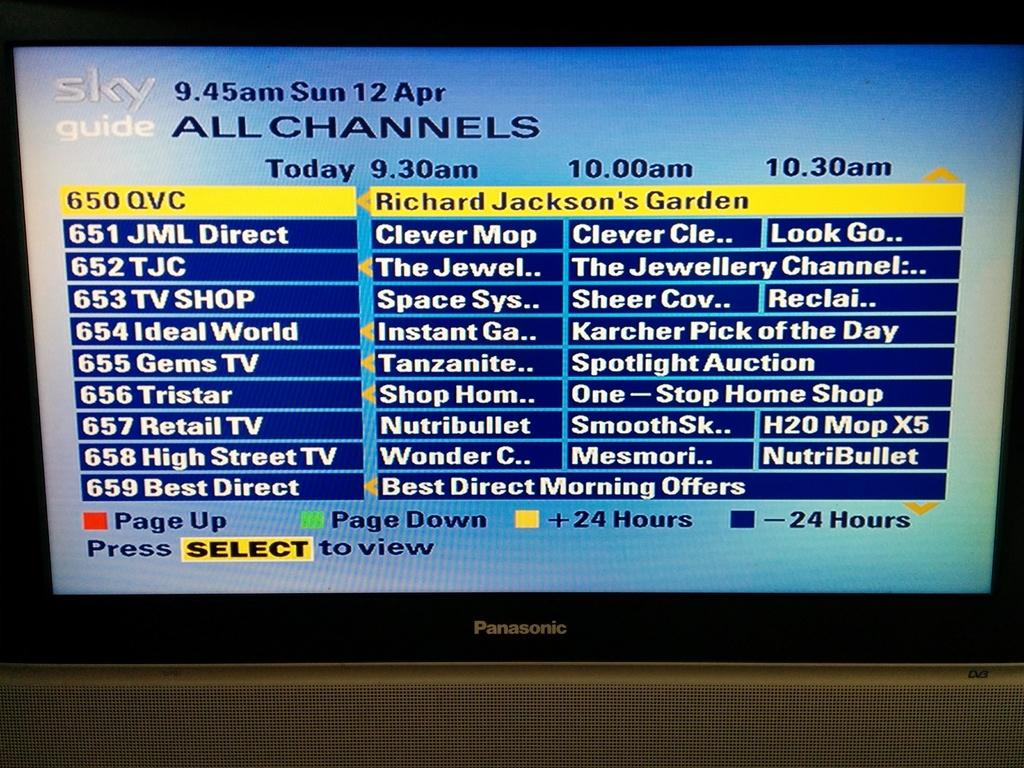Provide a one-sentence caption for the provided image. Panasonic television that is on the guide channels. 